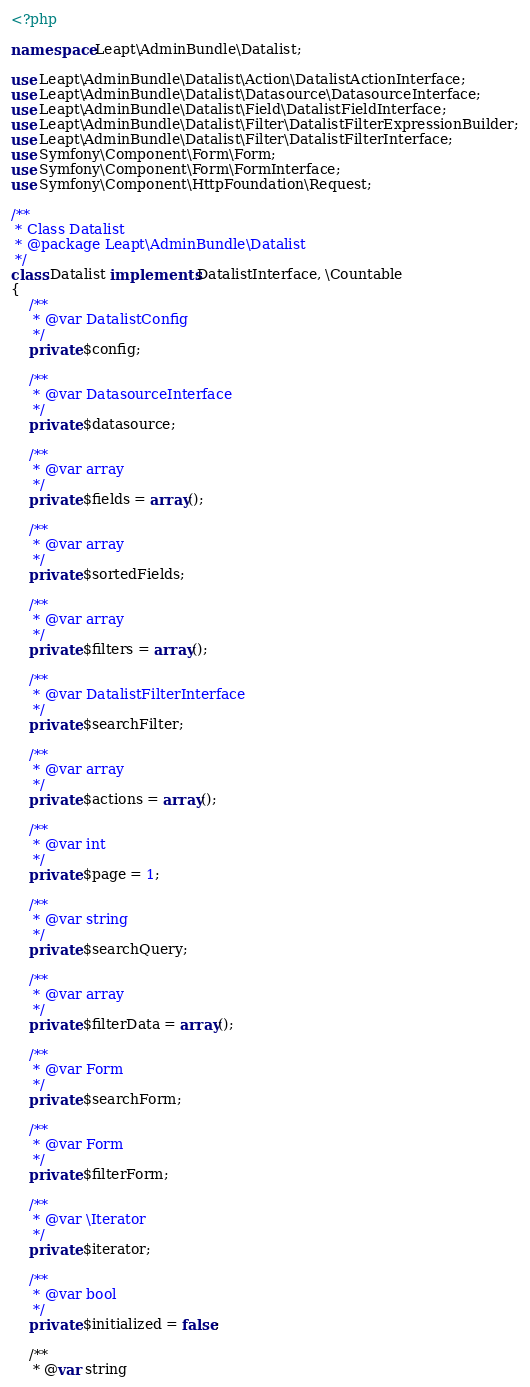<code> <loc_0><loc_0><loc_500><loc_500><_PHP_><?php

namespace Leapt\AdminBundle\Datalist;

use Leapt\AdminBundle\Datalist\Action\DatalistActionInterface;
use Leapt\AdminBundle\Datalist\Datasource\DatasourceInterface;
use Leapt\AdminBundle\Datalist\Field\DatalistFieldInterface;
use Leapt\AdminBundle\Datalist\Filter\DatalistFilterExpressionBuilder;
use Leapt\AdminBundle\Datalist\Filter\DatalistFilterInterface;
use Symfony\Component\Form\Form;
use Symfony\Component\Form\FormInterface;
use Symfony\Component\HttpFoundation\Request;

/**
 * Class Datalist
 * @package Leapt\AdminBundle\Datalist
 */
class Datalist implements DatalistInterface, \Countable
{
    /**
     * @var DatalistConfig
     */
    private $config;

    /**
     * @var DatasourceInterface
     */
    private $datasource;

    /**
     * @var array
     */
    private $fields = array();

    /**
     * @var array
     */
    private $sortedFields;

    /**
     * @var array
     */
    private $filters = array();

    /**
     * @var DatalistFilterInterface
     */
    private $searchFilter;

    /**
     * @var array
     */
    private $actions = array();

    /**
     * @var int
     */
    private $page = 1;

    /**
     * @var string
     */
    private $searchQuery;

    /**
     * @var array
     */
    private $filterData = array();

    /**
     * @var Form
     */
    private $searchForm;

    /**
     * @var Form
     */
    private $filterForm;

    /**
     * @var \Iterator
     */
    private $iterator;

    /**
     * @var bool
     */
    private $initialized = false;

    /**
     * @var string</code> 